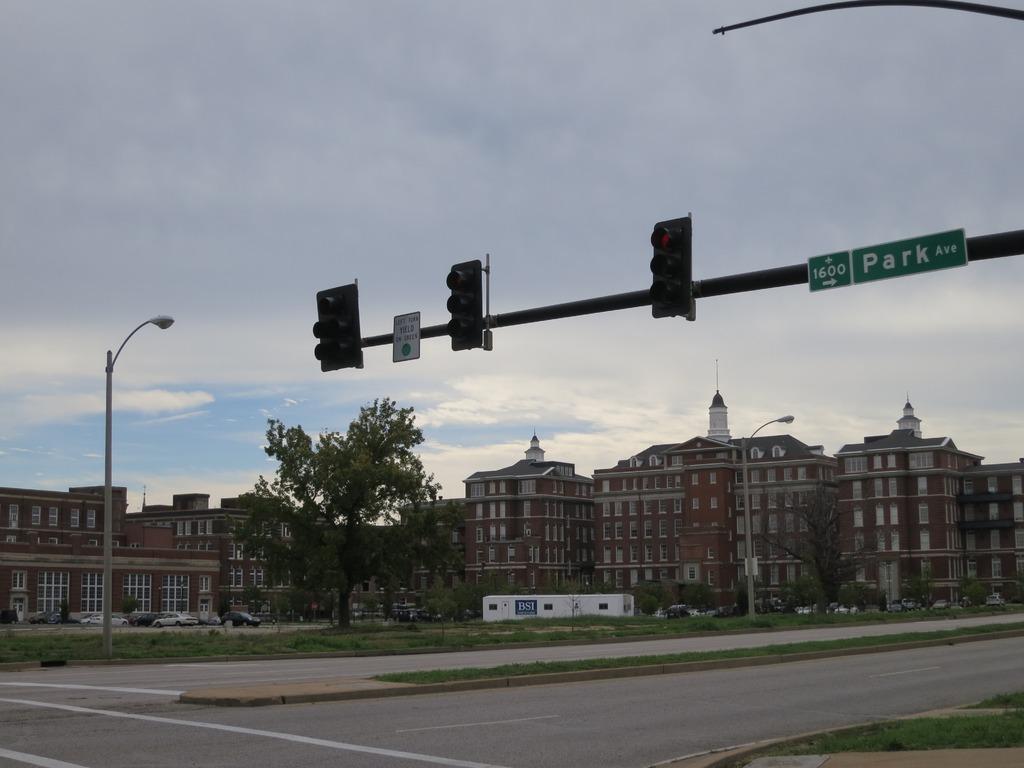What specific part of park ave is this location?
Provide a succinct answer. 1600. 